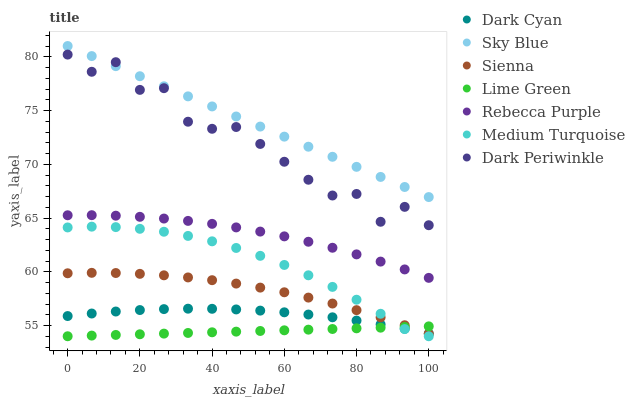Does Lime Green have the minimum area under the curve?
Answer yes or no. Yes. Does Sky Blue have the maximum area under the curve?
Answer yes or no. Yes. Does Rebecca Purple have the minimum area under the curve?
Answer yes or no. No. Does Rebecca Purple have the maximum area under the curve?
Answer yes or no. No. Is Lime Green the smoothest?
Answer yes or no. Yes. Is Dark Periwinkle the roughest?
Answer yes or no. Yes. Is Rebecca Purple the smoothest?
Answer yes or no. No. Is Rebecca Purple the roughest?
Answer yes or no. No. Does Medium Turquoise have the lowest value?
Answer yes or no. Yes. Does Rebecca Purple have the lowest value?
Answer yes or no. No. Does Sky Blue have the highest value?
Answer yes or no. Yes. Does Rebecca Purple have the highest value?
Answer yes or no. No. Is Lime Green less than Rebecca Purple?
Answer yes or no. Yes. Is Sky Blue greater than Lime Green?
Answer yes or no. Yes. Does Dark Cyan intersect Lime Green?
Answer yes or no. Yes. Is Dark Cyan less than Lime Green?
Answer yes or no. No. Is Dark Cyan greater than Lime Green?
Answer yes or no. No. Does Lime Green intersect Rebecca Purple?
Answer yes or no. No. 